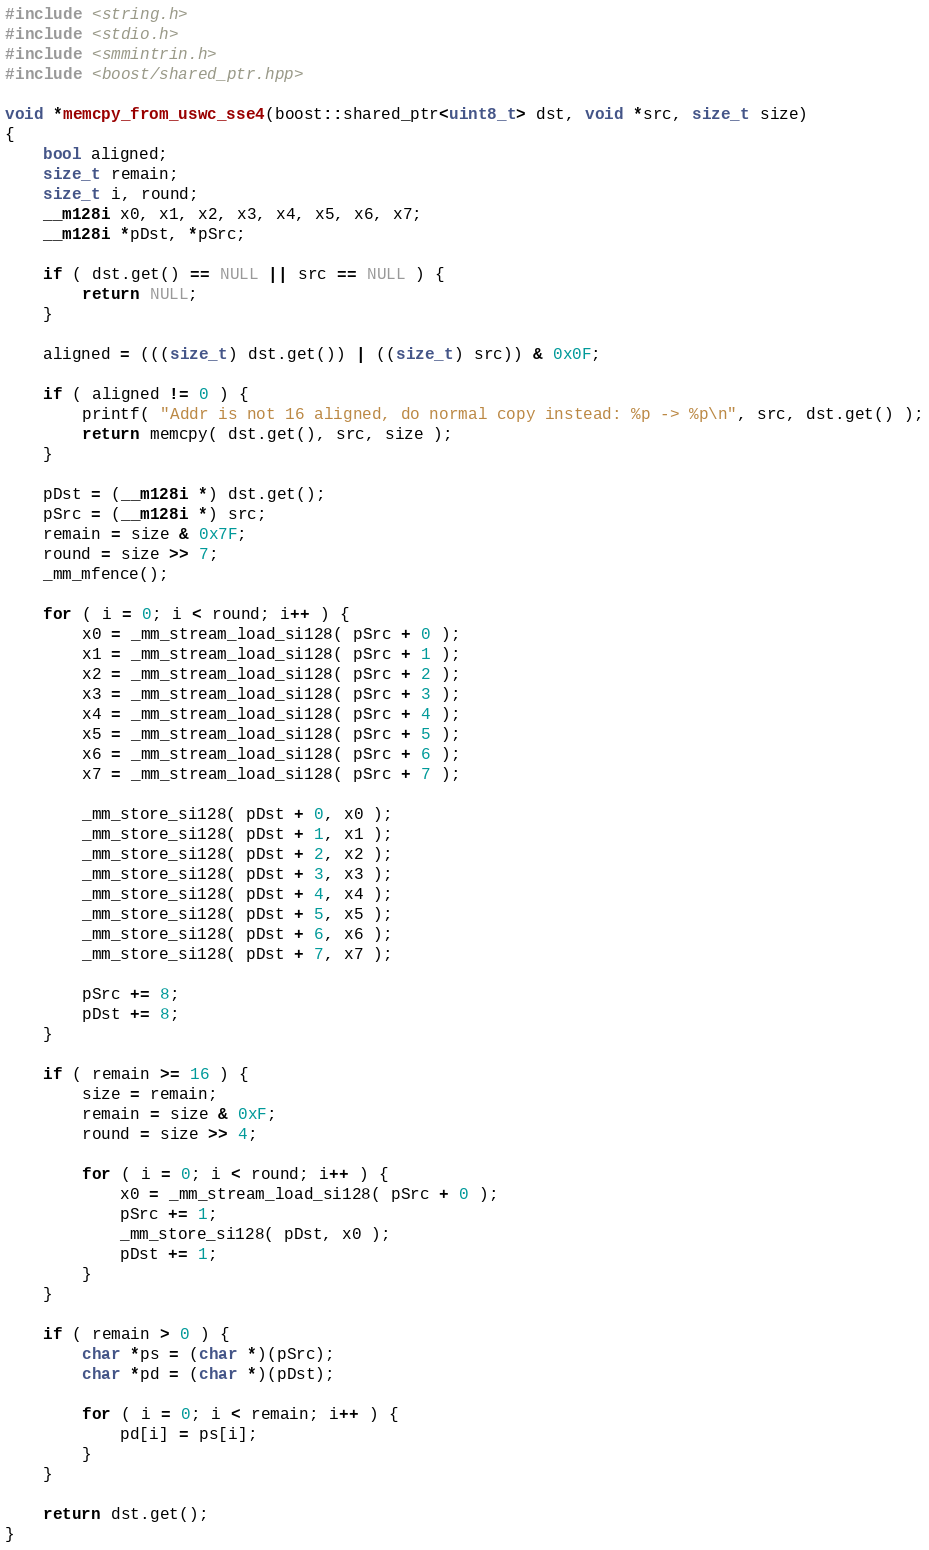<code> <loc_0><loc_0><loc_500><loc_500><_C++_>#include <string.h>
#include <stdio.h>
#include <smmintrin.h>
#include <boost/shared_ptr.hpp>

void *memcpy_from_uswc_sse4(boost::shared_ptr<uint8_t> dst, void *src, size_t size)
{
    bool aligned;
    size_t remain;
    size_t i, round;
    __m128i x0, x1, x2, x3, x4, x5, x6, x7;
    __m128i *pDst, *pSrc;

    if ( dst.get() == NULL || src == NULL ) {
        return NULL;
    }

    aligned = (((size_t) dst.get()) | ((size_t) src)) & 0x0F;

    if ( aligned != 0 ) {
        printf( "Addr is not 16 aligned, do normal copy instead: %p -> %p\n", src, dst.get() );
        return memcpy( dst.get(), src, size );
    }

    pDst = (__m128i *) dst.get();
    pSrc = (__m128i *) src;
    remain = size & 0x7F;
    round = size >> 7;
    _mm_mfence();

    for ( i = 0; i < round; i++ ) {
        x0 = _mm_stream_load_si128( pSrc + 0 );
        x1 = _mm_stream_load_si128( pSrc + 1 );
        x2 = _mm_stream_load_si128( pSrc + 2 );
        x3 = _mm_stream_load_si128( pSrc + 3 );
        x4 = _mm_stream_load_si128( pSrc + 4 );
        x5 = _mm_stream_load_si128( pSrc + 5 );
        x6 = _mm_stream_load_si128( pSrc + 6 );
        x7 = _mm_stream_load_si128( pSrc + 7 );

        _mm_store_si128( pDst + 0, x0 );
        _mm_store_si128( pDst + 1, x1 );
        _mm_store_si128( pDst + 2, x2 );
        _mm_store_si128( pDst + 3, x3 );
        _mm_store_si128( pDst + 4, x4 );
        _mm_store_si128( pDst + 5, x5 );
        _mm_store_si128( pDst + 6, x6 );
        _mm_store_si128( pDst + 7, x7 );

        pSrc += 8;
        pDst += 8;
    }

    if ( remain >= 16 ) {
        size = remain;
        remain = size & 0xF;
        round = size >> 4;

        for ( i = 0; i < round; i++ ) {
            x0 = _mm_stream_load_si128( pSrc + 0 );
            pSrc += 1;
            _mm_store_si128( pDst, x0 );
            pDst += 1;
        }
    }

    if ( remain > 0 ) {
        char *ps = (char *)(pSrc);
        char *pd = (char *)(pDst);

        for ( i = 0; i < remain; i++ ) {
            pd[i] = ps[i];
        }
    }

    return dst.get();
}

</code> 